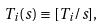Convert formula to latex. <formula><loc_0><loc_0><loc_500><loc_500>T _ { i } ( s ) \equiv [ T _ { i } / s ] ,</formula> 